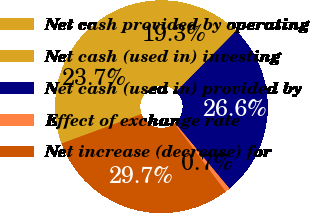<chart> <loc_0><loc_0><loc_500><loc_500><pie_chart><fcel>Net cash provided by operating<fcel>Net cash (used in) investing<fcel>Net cash (used in) provided by<fcel>Effect of exchange rate<fcel>Net increase (decrease) for<nl><fcel>23.7%<fcel>19.3%<fcel>26.6%<fcel>0.72%<fcel>29.69%<nl></chart> 